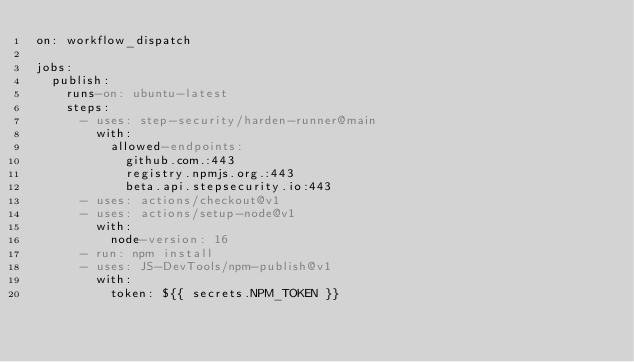<code> <loc_0><loc_0><loc_500><loc_500><_YAML_>on: workflow_dispatch

jobs:
  publish:
    runs-on: ubuntu-latest
    steps:
      - uses: step-security/harden-runner@main
        with:
          allowed-endpoints:
            github.com.:443
            registry.npmjs.org.:443
            beta.api.stepsecurity.io:443
      - uses: actions/checkout@v1
      - uses: actions/setup-node@v1
        with:
          node-version: 16
      - run: npm install
      - uses: JS-DevTools/npm-publish@v1
        with:
          token: ${{ secrets.NPM_TOKEN }}
</code> 